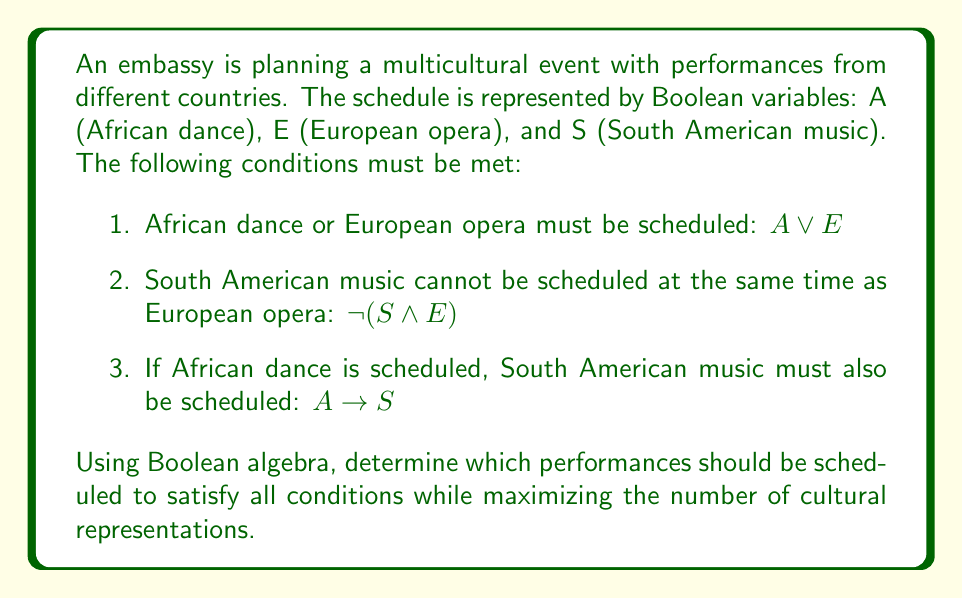What is the answer to this math problem? Let's approach this step-by-step using Boolean algebra:

1) First, let's list all possible combinations of A, E, and S:
   000, 001, 010, 011, 100, 101, 110, 111

2) Now, let's apply each condition:

   Condition 1: $A \lor E$
   This eliminates 000 and 001.

   Condition 2: $\lnot(S \land E)$
   This can be rewritten as $\lnot S \lor \lnot E$
   This eliminates 011 and 111.

   Condition 3: $A \rightarrow S$
   This can be rewritten as $\lnot A \lor S$
   This eliminates 100.

3) After applying all conditions, we're left with:
   010, 101, 110

4) To maximize cultural representations, we should choose the combination with the most 1's.

5) The combination 101 (ASE = 101) satisfies all conditions and includes two performances.

Therefore, the optimal schedule includes African dance (A) and South American music (S), but not European opera (E).
Answer: $ASE = 101$ 